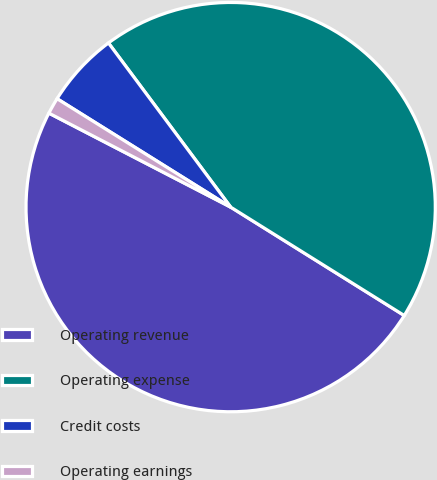<chart> <loc_0><loc_0><loc_500><loc_500><pie_chart><fcel>Operating revenue<fcel>Operating expense<fcel>Credit costs<fcel>Operating earnings<nl><fcel>48.71%<fcel>44.07%<fcel>5.93%<fcel>1.29%<nl></chart> 